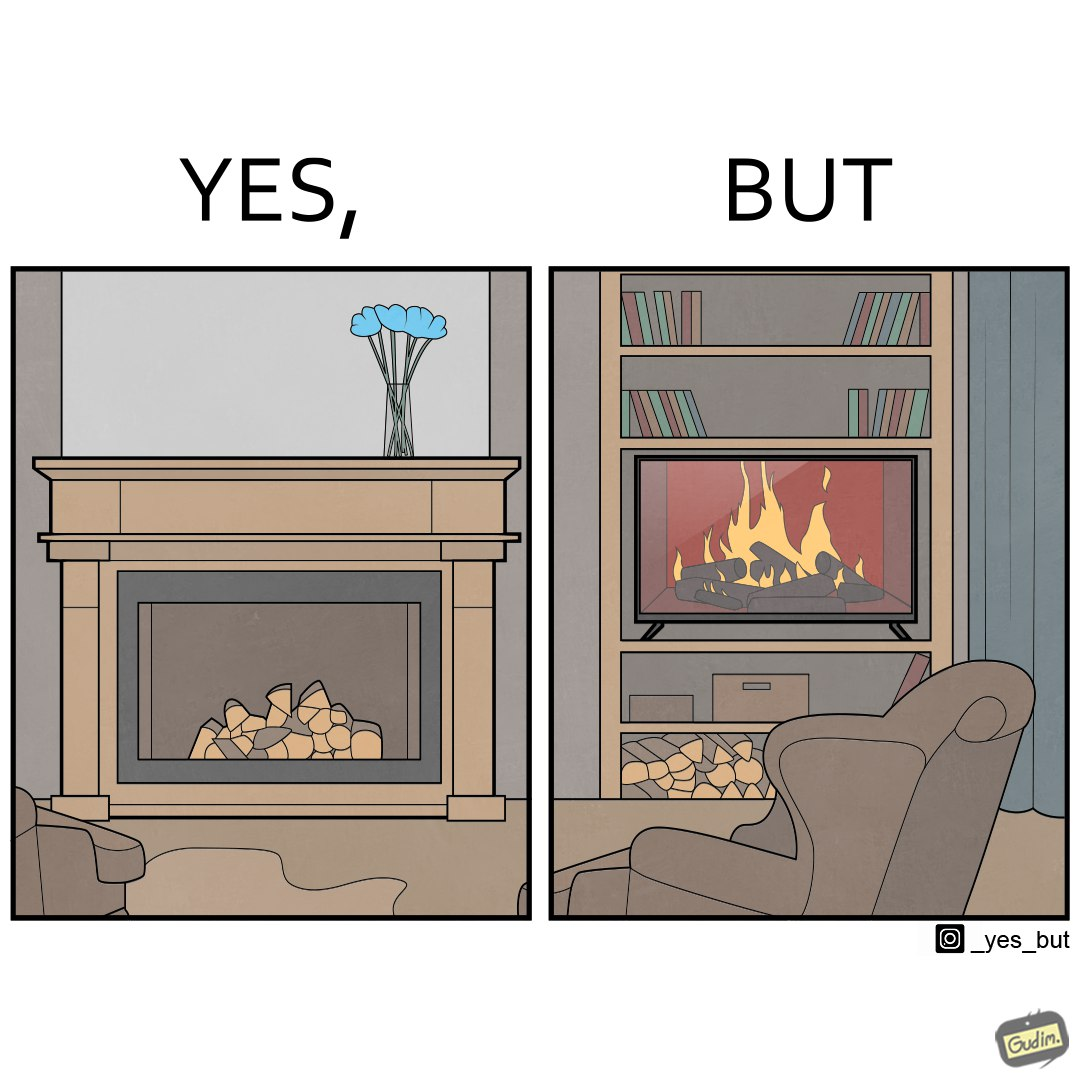Explain the humor or irony in this image. The images are funny since they show how even though real fireplaces exist, people choose to be lazy and watch fireplaces on television because they dont want the inconveniences of cleaning up, etc. afterwards 